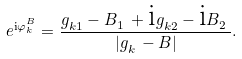Convert formula to latex. <formula><loc_0><loc_0><loc_500><loc_500>e ^ { \text {i} \varphi ^ { B } _ { k } } = \frac { g ^ { \ } _ { k 1 } - B ^ { \ } _ { 1 } + \text {i} g ^ { \ } _ { k 2 } - \text {i} B ^ { \ } _ { 2 } } { | g ^ { \ } _ { k } - B | } .</formula> 